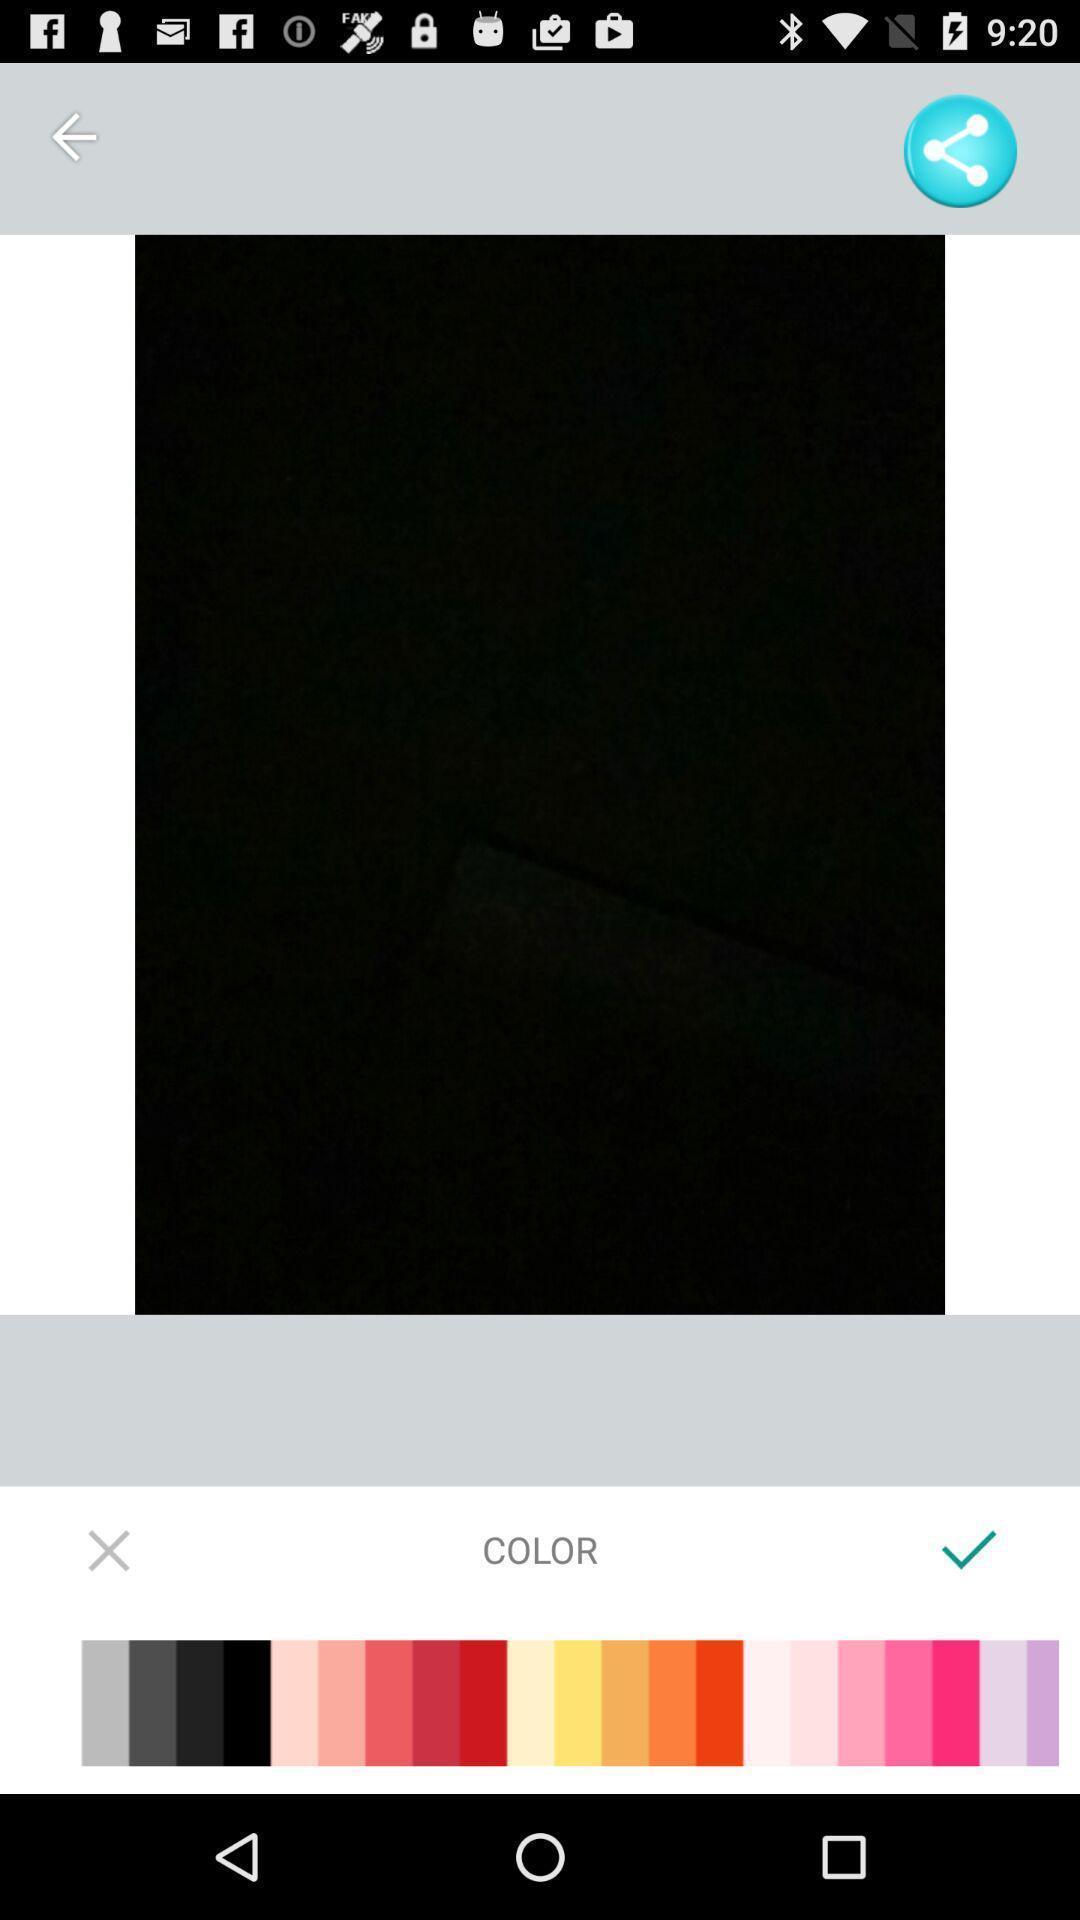Please provide a description for this image. Push up displaying to select filters. 